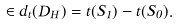<formula> <loc_0><loc_0><loc_500><loc_500>\in d _ { t } ( D _ { H } ) = t ( S _ { 1 } ) - t ( S _ { 0 } ) .</formula> 